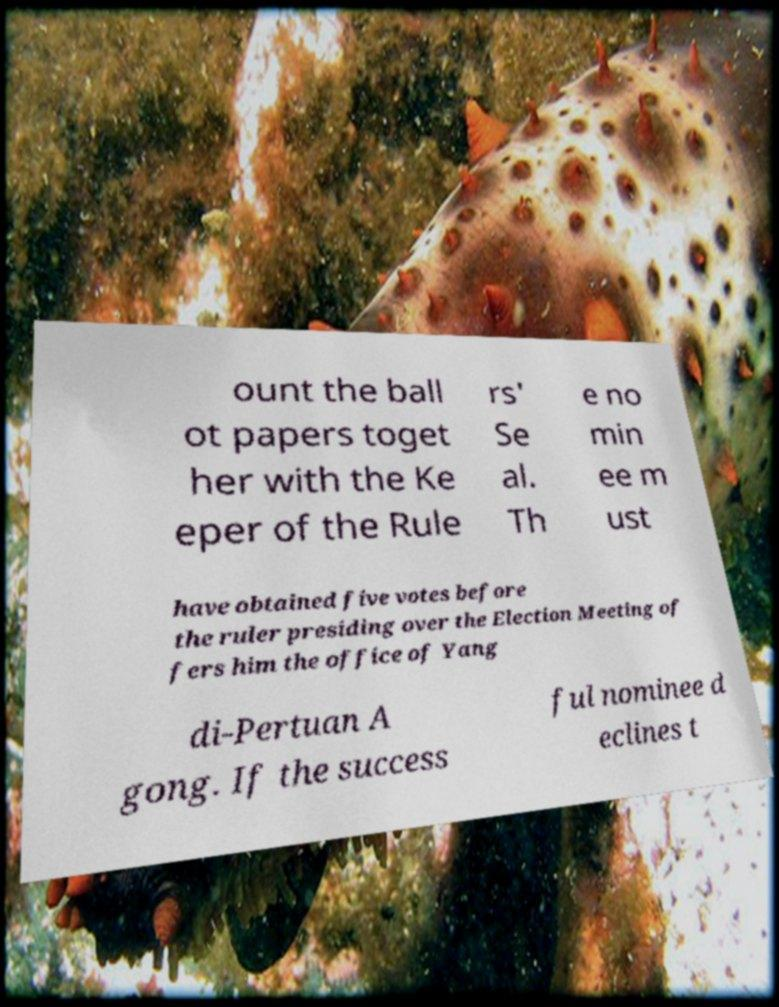I need the written content from this picture converted into text. Can you do that? ount the ball ot papers toget her with the Ke eper of the Rule rs' Se al. Th e no min ee m ust have obtained five votes before the ruler presiding over the Election Meeting of fers him the office of Yang di-Pertuan A gong. If the success ful nominee d eclines t 